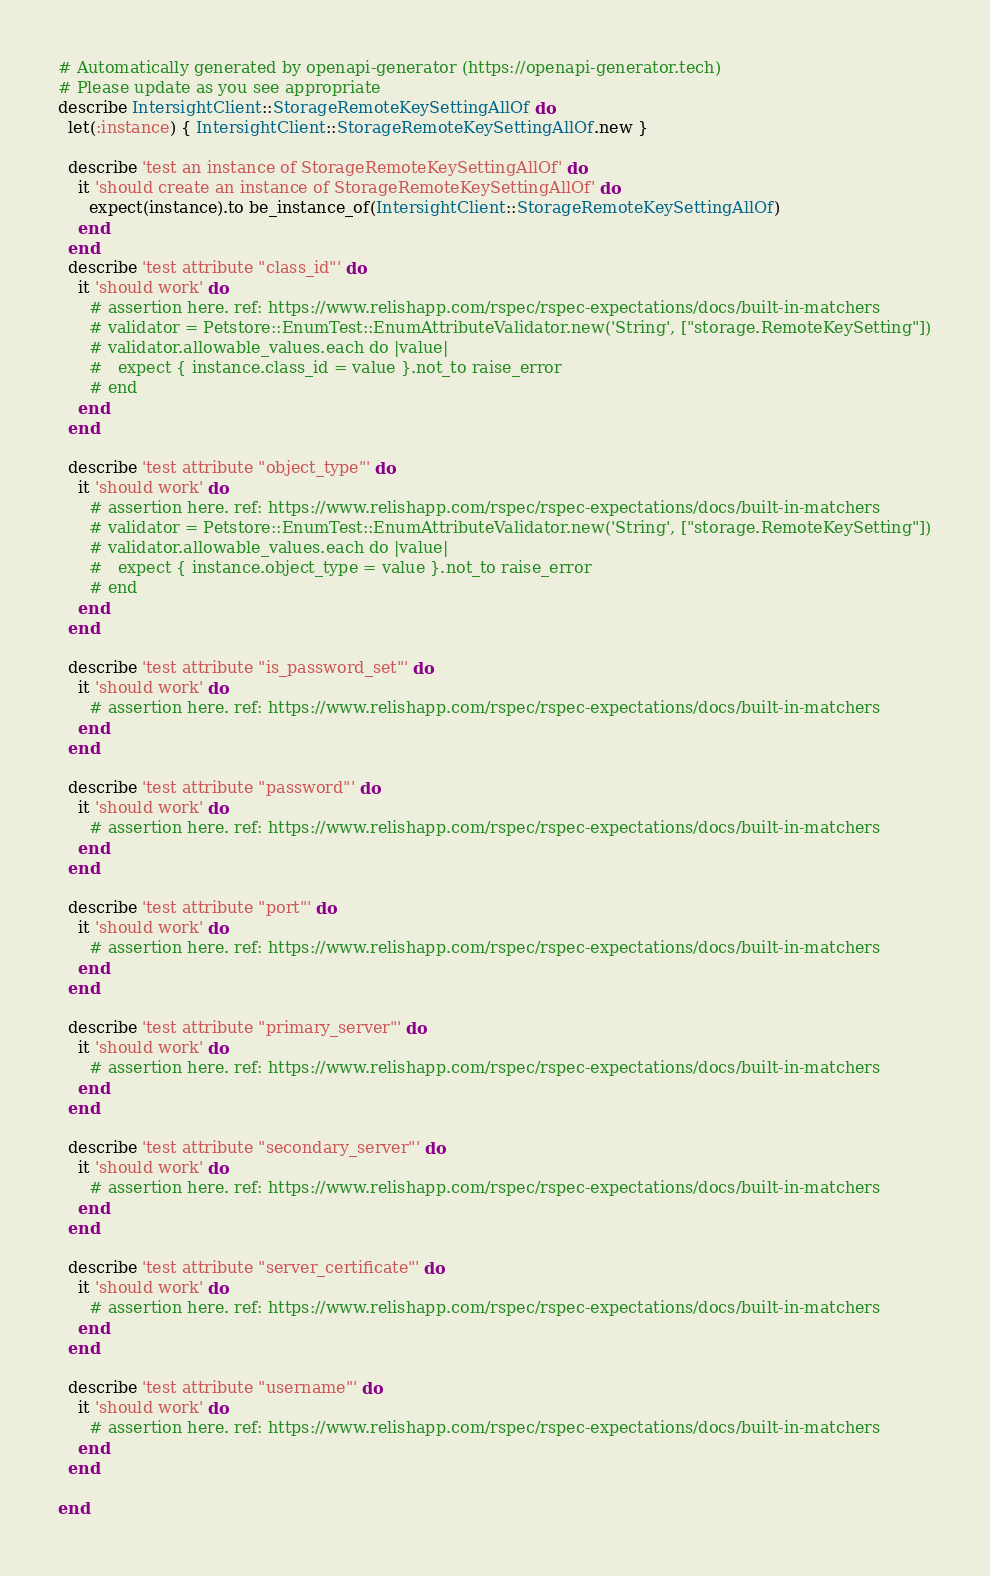Convert code to text. <code><loc_0><loc_0><loc_500><loc_500><_Ruby_># Automatically generated by openapi-generator (https://openapi-generator.tech)
# Please update as you see appropriate
describe IntersightClient::StorageRemoteKeySettingAllOf do
  let(:instance) { IntersightClient::StorageRemoteKeySettingAllOf.new }

  describe 'test an instance of StorageRemoteKeySettingAllOf' do
    it 'should create an instance of StorageRemoteKeySettingAllOf' do
      expect(instance).to be_instance_of(IntersightClient::StorageRemoteKeySettingAllOf)
    end
  end
  describe 'test attribute "class_id"' do
    it 'should work' do
      # assertion here. ref: https://www.relishapp.com/rspec/rspec-expectations/docs/built-in-matchers
      # validator = Petstore::EnumTest::EnumAttributeValidator.new('String', ["storage.RemoteKeySetting"])
      # validator.allowable_values.each do |value|
      #   expect { instance.class_id = value }.not_to raise_error
      # end
    end
  end

  describe 'test attribute "object_type"' do
    it 'should work' do
      # assertion here. ref: https://www.relishapp.com/rspec/rspec-expectations/docs/built-in-matchers
      # validator = Petstore::EnumTest::EnumAttributeValidator.new('String', ["storage.RemoteKeySetting"])
      # validator.allowable_values.each do |value|
      #   expect { instance.object_type = value }.not_to raise_error
      # end
    end
  end

  describe 'test attribute "is_password_set"' do
    it 'should work' do
      # assertion here. ref: https://www.relishapp.com/rspec/rspec-expectations/docs/built-in-matchers
    end
  end

  describe 'test attribute "password"' do
    it 'should work' do
      # assertion here. ref: https://www.relishapp.com/rspec/rspec-expectations/docs/built-in-matchers
    end
  end

  describe 'test attribute "port"' do
    it 'should work' do
      # assertion here. ref: https://www.relishapp.com/rspec/rspec-expectations/docs/built-in-matchers
    end
  end

  describe 'test attribute "primary_server"' do
    it 'should work' do
      # assertion here. ref: https://www.relishapp.com/rspec/rspec-expectations/docs/built-in-matchers
    end
  end

  describe 'test attribute "secondary_server"' do
    it 'should work' do
      # assertion here. ref: https://www.relishapp.com/rspec/rspec-expectations/docs/built-in-matchers
    end
  end

  describe 'test attribute "server_certificate"' do
    it 'should work' do
      # assertion here. ref: https://www.relishapp.com/rspec/rspec-expectations/docs/built-in-matchers
    end
  end

  describe 'test attribute "username"' do
    it 'should work' do
      # assertion here. ref: https://www.relishapp.com/rspec/rspec-expectations/docs/built-in-matchers
    end
  end

end
</code> 